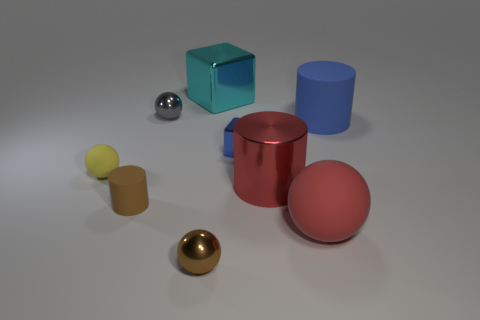Subtract all big cylinders. How many cylinders are left? 1 Subtract all blue cubes. How many cubes are left? 1 Subtract 1 spheres. How many spheres are left? 3 Add 1 gray spheres. How many objects exist? 10 Subtract all yellow cubes. Subtract all green cylinders. How many cubes are left? 2 Subtract all cyan spheres. How many blue cubes are left? 1 Subtract all cylinders. How many objects are left? 6 Add 5 gray spheres. How many gray spheres are left? 6 Add 6 tiny cyan spheres. How many tiny cyan spheres exist? 6 Subtract 0 blue spheres. How many objects are left? 9 